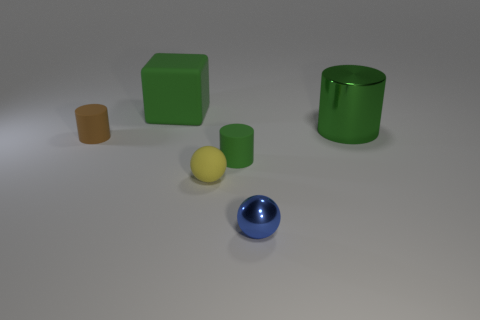Could you give me a sense of the size order of these objects? Of course, based on their apparent dimensions relative to each other, the size order from largest to smallest would be: the green cube, the green cylinder, the yellow cylinder, the blue sphere, and the brown rectangular prism. And which objects have the same color? The green cube and the green cylinder share the same color; they are both shades of green. 